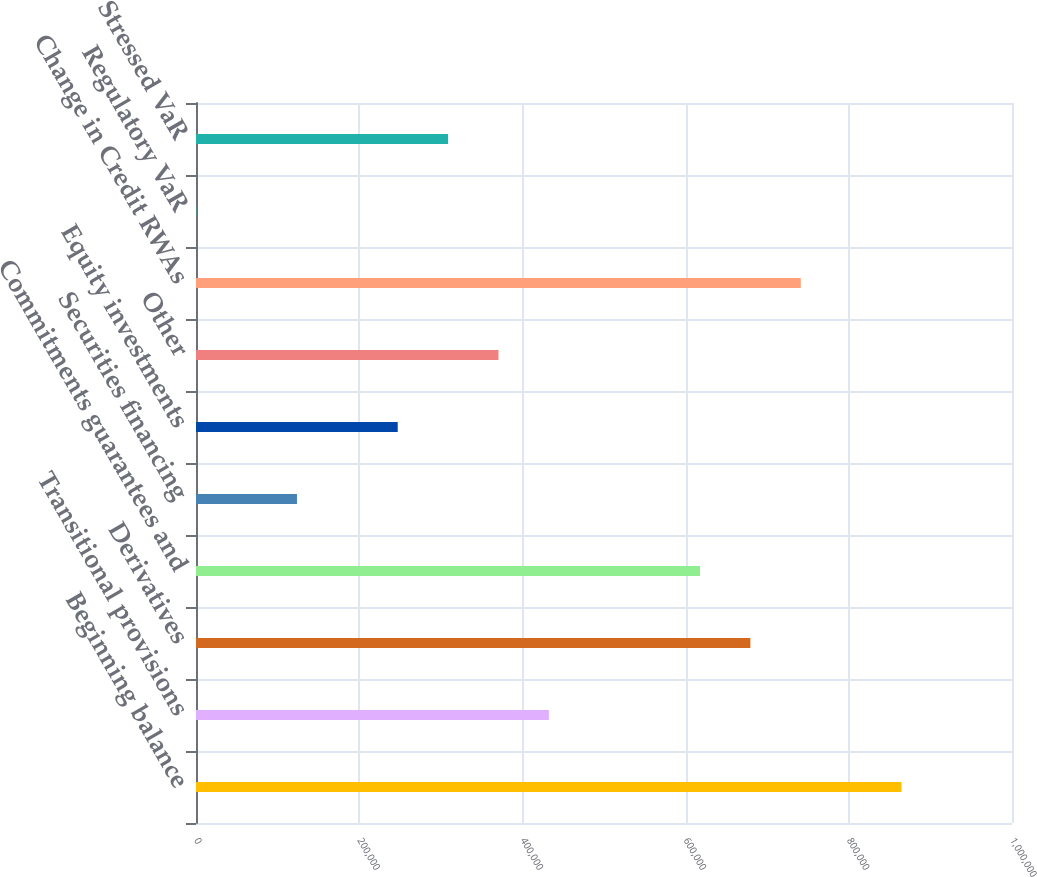Convert chart. <chart><loc_0><loc_0><loc_500><loc_500><bar_chart><fcel>Beginning balance<fcel>Transitional provisions<fcel>Derivatives<fcel>Commitments guarantees and<fcel>Securities financing<fcel>Equity investments<fcel>Other<fcel>Change in Credit RWAs<fcel>Regulatory VaR<fcel>Stressed VaR<nl><fcel>864604<fcel>432427<fcel>679386<fcel>617646<fcel>123729<fcel>247208<fcel>370688<fcel>741125<fcel>250<fcel>308948<nl></chart> 